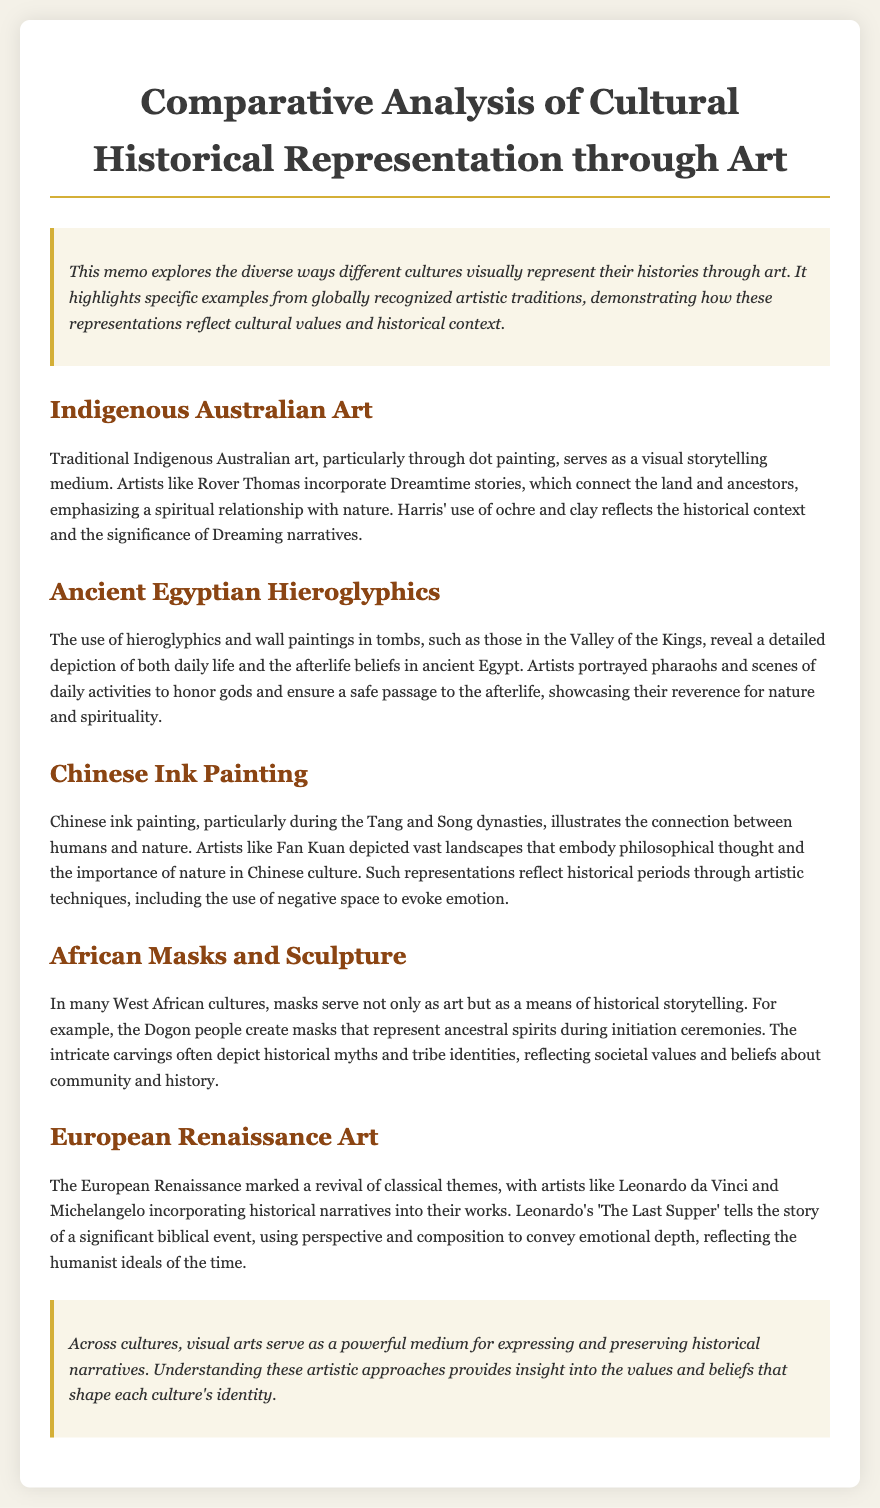What art form is used by Indigenous Australians for storytelling? The memo states that traditional Indigenous Australian art uses dot painting as a medium for visual storytelling.
Answer: dot painting Which artist is mentioned in connection with Dreamtime stories? Rover Thomas is highlighted as an artist who incorporates Dreamtime stories into his work.
Answer: Rover Thomas What artistic technique is emphasized in Chinese ink painting from the Tang and Song dynasties? The memo mentions the use of negative space in Chinese ink painting to evoke emotion.
Answer: negative space What do the Dogon masks represent in their culture? The document states that masks created by the Dogon people represent ancestral spirits during initiation ceremonies.
Answer: ancestral spirits Which biblical event is depicted in Leonardo da Vinci's artwork mentioned in the memo? The memo references 'The Last Supper', which tells the story of a significant biblical event.
Answer: The Last Supper What is the main purpose of ancient Egyptian wall paintings in tombs? The memo notes that wall paintings in tombs aim to honor gods and ensure a safe passage to the afterlife.
Answer: honor gods and ensure a safe passage What cultural aspect do African masks reflect according to the document? The document indicates that African masks reflect societal values and beliefs about community and history.
Answer: societal values and beliefs In what historical period did the European Renaissance occur? The document indicates that the European Renaissance was a revival of classical themes, but it does not provide a specific date.
Answer: Renaissance What does the document conclude about visual arts across cultures? The conclusion states that visual arts serve as a powerful medium for expressing and preserving historical narratives.
Answer: powerful medium for expressing and preserving historical narratives 